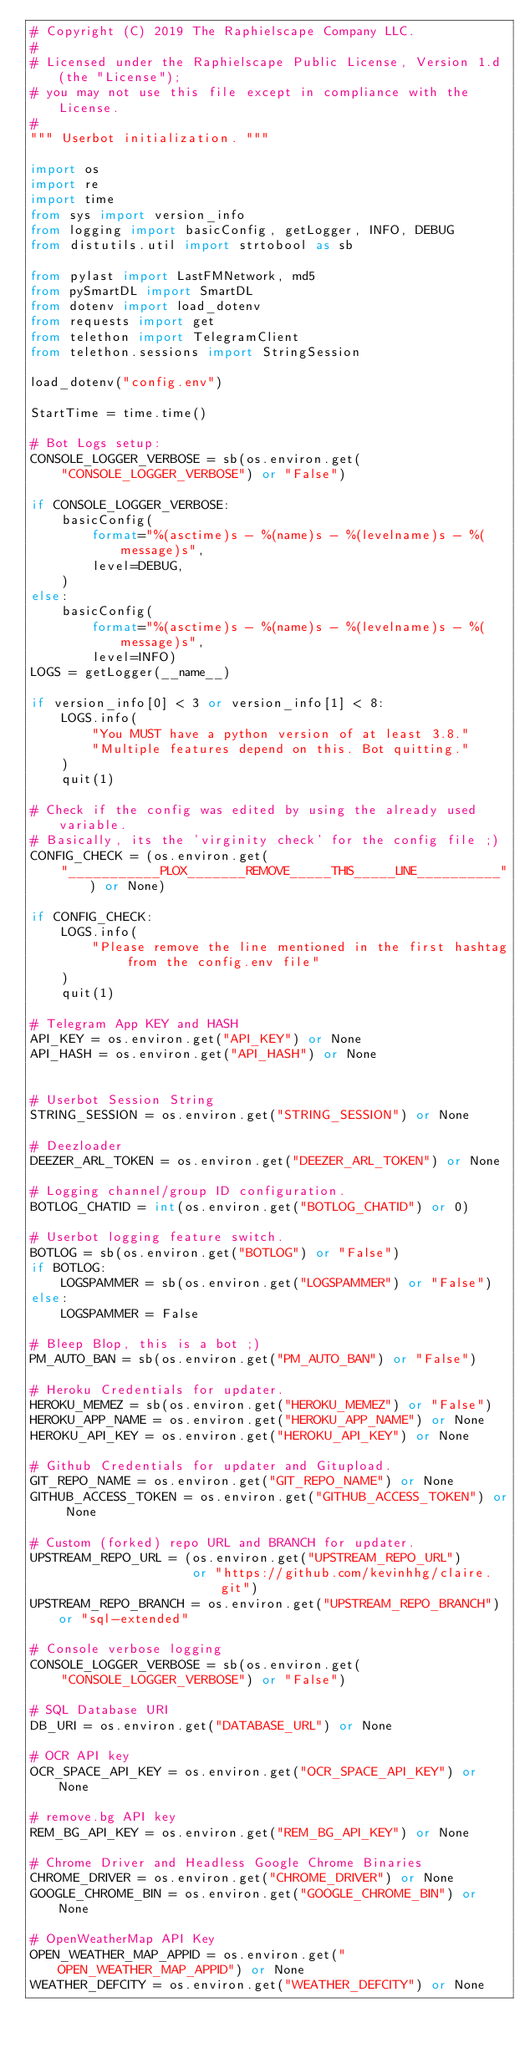<code> <loc_0><loc_0><loc_500><loc_500><_Python_># Copyright (C) 2019 The Raphielscape Company LLC.
#
# Licensed under the Raphielscape Public License, Version 1.d (the "License");
# you may not use this file except in compliance with the License.
#
""" Userbot initialization. """

import os
import re
import time
from sys import version_info
from logging import basicConfig, getLogger, INFO, DEBUG
from distutils.util import strtobool as sb

from pylast import LastFMNetwork, md5
from pySmartDL import SmartDL
from dotenv import load_dotenv
from requests import get
from telethon import TelegramClient
from telethon.sessions import StringSession

load_dotenv("config.env")

StartTime = time.time()

# Bot Logs setup:
CONSOLE_LOGGER_VERBOSE = sb(os.environ.get(
    "CONSOLE_LOGGER_VERBOSE") or "False")

if CONSOLE_LOGGER_VERBOSE:
    basicConfig(
        format="%(asctime)s - %(name)s - %(levelname)s - %(message)s",
        level=DEBUG,
    )
else:
    basicConfig(
        format="%(asctime)s - %(name)s - %(levelname)s - %(message)s",
        level=INFO)
LOGS = getLogger(__name__)

if version_info[0] < 3 or version_info[1] < 8:
    LOGS.info(
        "You MUST have a python version of at least 3.8."
        "Multiple features depend on this. Bot quitting."
    )
    quit(1)

# Check if the config was edited by using the already used variable.
# Basically, its the 'virginity check' for the config file ;)
CONFIG_CHECK = (os.environ.get(
    "___________PLOX_______REMOVE_____THIS_____LINE__________") or None)

if CONFIG_CHECK:
    LOGS.info(
        "Please remove the line mentioned in the first hashtag from the config.env file"
    )
    quit(1)

# Telegram App KEY and HASH
API_KEY = os.environ.get("API_KEY") or None
API_HASH = os.environ.get("API_HASH") or None


# Userbot Session String
STRING_SESSION = os.environ.get("STRING_SESSION") or None

# Deezloader
DEEZER_ARL_TOKEN = os.environ.get("DEEZER_ARL_TOKEN") or None

# Logging channel/group ID configuration.
BOTLOG_CHATID = int(os.environ.get("BOTLOG_CHATID") or 0)

# Userbot logging feature switch.
BOTLOG = sb(os.environ.get("BOTLOG") or "False")
if BOTLOG:
    LOGSPAMMER = sb(os.environ.get("LOGSPAMMER") or "False")
else:
    LOGSPAMMER = False

# Bleep Blop, this is a bot ;)
PM_AUTO_BAN = sb(os.environ.get("PM_AUTO_BAN") or "False")

# Heroku Credentials for updater.
HEROKU_MEMEZ = sb(os.environ.get("HEROKU_MEMEZ") or "False")
HEROKU_APP_NAME = os.environ.get("HEROKU_APP_NAME") or None
HEROKU_API_KEY = os.environ.get("HEROKU_API_KEY") or None

# Github Credentials for updater and Gitupload.
GIT_REPO_NAME = os.environ.get("GIT_REPO_NAME") or None
GITHUB_ACCESS_TOKEN = os.environ.get("GITHUB_ACCESS_TOKEN") or None

# Custom (forked) repo URL and BRANCH for updater.
UPSTREAM_REPO_URL = (os.environ.get("UPSTREAM_REPO_URL")
                     or "https://github.com/kevinhhg/claire.git")
UPSTREAM_REPO_BRANCH = os.environ.get("UPSTREAM_REPO_BRANCH") or "sql-extended"

# Console verbose logging
CONSOLE_LOGGER_VERBOSE = sb(os.environ.get(
    "CONSOLE_LOGGER_VERBOSE") or "False")

# SQL Database URI
DB_URI = os.environ.get("DATABASE_URL") or None

# OCR API key
OCR_SPACE_API_KEY = os.environ.get("OCR_SPACE_API_KEY") or None

# remove.bg API key
REM_BG_API_KEY = os.environ.get("REM_BG_API_KEY") or None

# Chrome Driver and Headless Google Chrome Binaries
CHROME_DRIVER = os.environ.get("CHROME_DRIVER") or None
GOOGLE_CHROME_BIN = os.environ.get("GOOGLE_CHROME_BIN") or None

# OpenWeatherMap API Key
OPEN_WEATHER_MAP_APPID = os.environ.get("OPEN_WEATHER_MAP_APPID") or None
WEATHER_DEFCITY = os.environ.get("WEATHER_DEFCITY") or None</code> 